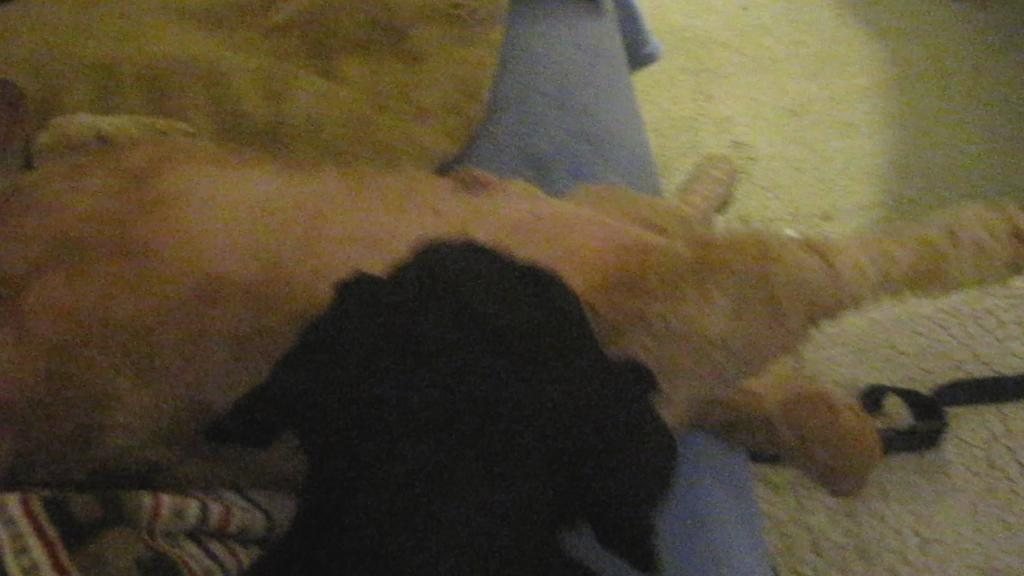How many dogs are in the image? There are two dogs in the image. What are the colors of the dogs? One dog is black, and the other is brown. Where are the dogs located in the image? The dogs are lying on a bed. What is visible at the bottom of the image? There is a floor mat at the bottom of the image. What type of rose can be seen in the image? There is no rose present in the image; it features two dogs lying on a bed. What level of education is being taught in the image? There is no school or educational activity depicted in the image. 